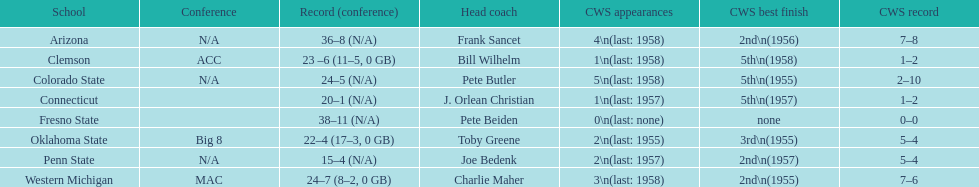How many teams reached their highest cws ranking in 1955? 3. 